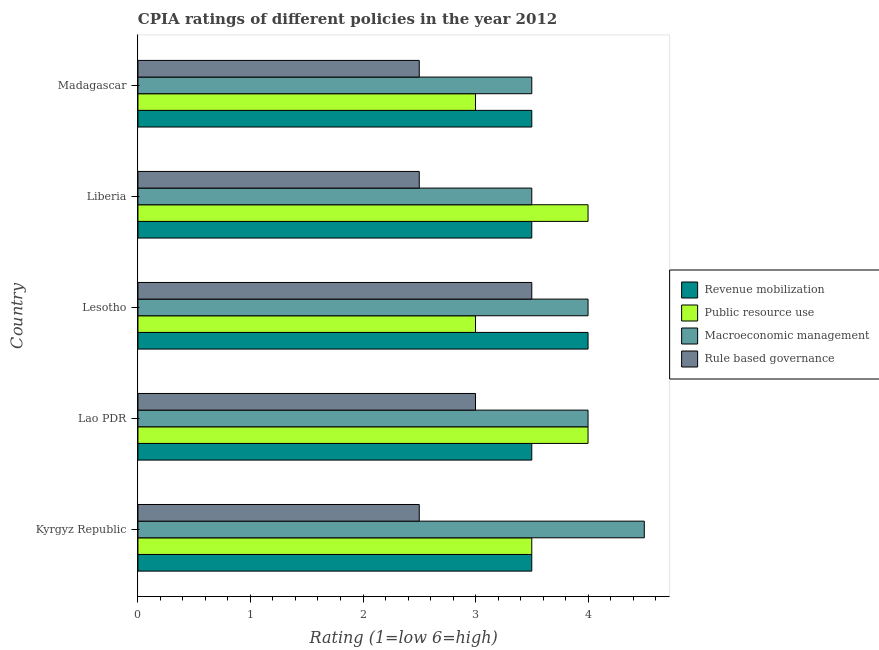Are the number of bars on each tick of the Y-axis equal?
Offer a terse response. Yes. How many bars are there on the 2nd tick from the bottom?
Provide a succinct answer. 4. What is the label of the 1st group of bars from the top?
Provide a succinct answer. Madagascar. In which country was the cpia rating of revenue mobilization maximum?
Offer a very short reply. Lesotho. In which country was the cpia rating of revenue mobilization minimum?
Provide a succinct answer. Kyrgyz Republic. What is the total cpia rating of macroeconomic management in the graph?
Offer a very short reply. 19.5. What is the difference between the cpia rating of macroeconomic management in Kyrgyz Republic and the cpia rating of public resource use in Liberia?
Your answer should be compact. 0.5. What is the average cpia rating of public resource use per country?
Keep it short and to the point. 3.5. What is the difference between the cpia rating of public resource use and cpia rating of revenue mobilization in Madagascar?
Provide a short and direct response. -0.5. In how many countries, is the cpia rating of macroeconomic management greater than 4.4 ?
Your response must be concise. 1. What is the ratio of the cpia rating of revenue mobilization in Kyrgyz Republic to that in Liberia?
Make the answer very short. 1. Is the cpia rating of macroeconomic management in Kyrgyz Republic less than that in Lao PDR?
Give a very brief answer. No. Is the difference between the cpia rating of macroeconomic management in Lesotho and Madagascar greater than the difference between the cpia rating of revenue mobilization in Lesotho and Madagascar?
Give a very brief answer. No. What is the difference between the highest and the lowest cpia rating of macroeconomic management?
Provide a succinct answer. 1. In how many countries, is the cpia rating of macroeconomic management greater than the average cpia rating of macroeconomic management taken over all countries?
Provide a succinct answer. 3. Is the sum of the cpia rating of revenue mobilization in Kyrgyz Republic and Liberia greater than the maximum cpia rating of rule based governance across all countries?
Provide a short and direct response. Yes. Is it the case that in every country, the sum of the cpia rating of macroeconomic management and cpia rating of public resource use is greater than the sum of cpia rating of rule based governance and cpia rating of revenue mobilization?
Your answer should be very brief. No. What does the 4th bar from the top in Liberia represents?
Keep it short and to the point. Revenue mobilization. What does the 1st bar from the bottom in Lesotho represents?
Give a very brief answer. Revenue mobilization. Is it the case that in every country, the sum of the cpia rating of revenue mobilization and cpia rating of public resource use is greater than the cpia rating of macroeconomic management?
Ensure brevity in your answer.  Yes. How many bars are there?
Make the answer very short. 20. How many countries are there in the graph?
Make the answer very short. 5. What is the difference between two consecutive major ticks on the X-axis?
Your answer should be very brief. 1. Where does the legend appear in the graph?
Provide a succinct answer. Center right. What is the title of the graph?
Provide a short and direct response. CPIA ratings of different policies in the year 2012. Does "SF6 gas" appear as one of the legend labels in the graph?
Provide a short and direct response. No. What is the label or title of the Y-axis?
Your answer should be compact. Country. What is the Rating (1=low 6=high) in Public resource use in Kyrgyz Republic?
Make the answer very short. 3.5. What is the Rating (1=low 6=high) of Rule based governance in Kyrgyz Republic?
Your answer should be compact. 2.5. What is the Rating (1=low 6=high) in Macroeconomic management in Lao PDR?
Ensure brevity in your answer.  4. What is the Rating (1=low 6=high) of Rule based governance in Lao PDR?
Give a very brief answer. 3. What is the Rating (1=low 6=high) in Rule based governance in Lesotho?
Ensure brevity in your answer.  3.5. What is the Rating (1=low 6=high) in Public resource use in Liberia?
Give a very brief answer. 4. What is the Rating (1=low 6=high) in Macroeconomic management in Liberia?
Keep it short and to the point. 3.5. What is the Rating (1=low 6=high) of Rule based governance in Liberia?
Keep it short and to the point. 2.5. What is the Rating (1=low 6=high) of Revenue mobilization in Madagascar?
Keep it short and to the point. 3.5. What is the Rating (1=low 6=high) of Public resource use in Madagascar?
Make the answer very short. 3. What is the Rating (1=low 6=high) in Rule based governance in Madagascar?
Give a very brief answer. 2.5. Across all countries, what is the maximum Rating (1=low 6=high) in Macroeconomic management?
Provide a succinct answer. 4.5. Across all countries, what is the minimum Rating (1=low 6=high) in Public resource use?
Give a very brief answer. 3. What is the total Rating (1=low 6=high) of Revenue mobilization in the graph?
Give a very brief answer. 18. What is the total Rating (1=low 6=high) of Macroeconomic management in the graph?
Your response must be concise. 19.5. What is the difference between the Rating (1=low 6=high) in Rule based governance in Kyrgyz Republic and that in Liberia?
Provide a short and direct response. 0. What is the difference between the Rating (1=low 6=high) in Revenue mobilization in Kyrgyz Republic and that in Madagascar?
Give a very brief answer. 0. What is the difference between the Rating (1=low 6=high) in Macroeconomic management in Kyrgyz Republic and that in Madagascar?
Your answer should be compact. 1. What is the difference between the Rating (1=low 6=high) in Public resource use in Lao PDR and that in Lesotho?
Your answer should be very brief. 1. What is the difference between the Rating (1=low 6=high) in Rule based governance in Lao PDR and that in Lesotho?
Offer a terse response. -0.5. What is the difference between the Rating (1=low 6=high) of Revenue mobilization in Lao PDR and that in Liberia?
Your answer should be compact. 0. What is the difference between the Rating (1=low 6=high) of Macroeconomic management in Lao PDR and that in Liberia?
Ensure brevity in your answer.  0.5. What is the difference between the Rating (1=low 6=high) of Public resource use in Lesotho and that in Liberia?
Your answer should be very brief. -1. What is the difference between the Rating (1=low 6=high) of Revenue mobilization in Liberia and that in Madagascar?
Give a very brief answer. 0. What is the difference between the Rating (1=low 6=high) in Macroeconomic management in Kyrgyz Republic and the Rating (1=low 6=high) in Rule based governance in Lao PDR?
Offer a very short reply. 1.5. What is the difference between the Rating (1=low 6=high) in Revenue mobilization in Kyrgyz Republic and the Rating (1=low 6=high) in Public resource use in Lesotho?
Make the answer very short. 0.5. What is the difference between the Rating (1=low 6=high) in Revenue mobilization in Kyrgyz Republic and the Rating (1=low 6=high) in Macroeconomic management in Lesotho?
Provide a short and direct response. -0.5. What is the difference between the Rating (1=low 6=high) in Revenue mobilization in Kyrgyz Republic and the Rating (1=low 6=high) in Rule based governance in Lesotho?
Keep it short and to the point. 0. What is the difference between the Rating (1=low 6=high) of Revenue mobilization in Kyrgyz Republic and the Rating (1=low 6=high) of Public resource use in Liberia?
Make the answer very short. -0.5. What is the difference between the Rating (1=low 6=high) in Revenue mobilization in Kyrgyz Republic and the Rating (1=low 6=high) in Rule based governance in Liberia?
Your answer should be compact. 1. What is the difference between the Rating (1=low 6=high) of Public resource use in Kyrgyz Republic and the Rating (1=low 6=high) of Macroeconomic management in Liberia?
Keep it short and to the point. 0. What is the difference between the Rating (1=low 6=high) in Macroeconomic management in Kyrgyz Republic and the Rating (1=low 6=high) in Rule based governance in Liberia?
Make the answer very short. 2. What is the difference between the Rating (1=low 6=high) of Revenue mobilization in Kyrgyz Republic and the Rating (1=low 6=high) of Rule based governance in Madagascar?
Ensure brevity in your answer.  1. What is the difference between the Rating (1=low 6=high) of Public resource use in Kyrgyz Republic and the Rating (1=low 6=high) of Macroeconomic management in Madagascar?
Give a very brief answer. 0. What is the difference between the Rating (1=low 6=high) of Public resource use in Kyrgyz Republic and the Rating (1=low 6=high) of Rule based governance in Madagascar?
Your response must be concise. 1. What is the difference between the Rating (1=low 6=high) of Macroeconomic management in Kyrgyz Republic and the Rating (1=low 6=high) of Rule based governance in Madagascar?
Provide a short and direct response. 2. What is the difference between the Rating (1=low 6=high) of Macroeconomic management in Lao PDR and the Rating (1=low 6=high) of Rule based governance in Lesotho?
Offer a terse response. 0.5. What is the difference between the Rating (1=low 6=high) of Revenue mobilization in Lao PDR and the Rating (1=low 6=high) of Macroeconomic management in Liberia?
Ensure brevity in your answer.  0. What is the difference between the Rating (1=low 6=high) of Revenue mobilization in Lao PDR and the Rating (1=low 6=high) of Rule based governance in Liberia?
Ensure brevity in your answer.  1. What is the difference between the Rating (1=low 6=high) in Public resource use in Lao PDR and the Rating (1=low 6=high) in Macroeconomic management in Liberia?
Keep it short and to the point. 0.5. What is the difference between the Rating (1=low 6=high) in Revenue mobilization in Lao PDR and the Rating (1=low 6=high) in Macroeconomic management in Madagascar?
Ensure brevity in your answer.  0. What is the difference between the Rating (1=low 6=high) of Revenue mobilization in Lao PDR and the Rating (1=low 6=high) of Rule based governance in Madagascar?
Provide a succinct answer. 1. What is the difference between the Rating (1=low 6=high) in Macroeconomic management in Lao PDR and the Rating (1=low 6=high) in Rule based governance in Madagascar?
Make the answer very short. 1.5. What is the difference between the Rating (1=low 6=high) in Revenue mobilization in Lesotho and the Rating (1=low 6=high) in Public resource use in Liberia?
Ensure brevity in your answer.  0. What is the difference between the Rating (1=low 6=high) in Public resource use in Lesotho and the Rating (1=low 6=high) in Macroeconomic management in Liberia?
Ensure brevity in your answer.  -0.5. What is the difference between the Rating (1=low 6=high) of Macroeconomic management in Lesotho and the Rating (1=low 6=high) of Rule based governance in Liberia?
Make the answer very short. 1.5. What is the difference between the Rating (1=low 6=high) in Revenue mobilization in Lesotho and the Rating (1=low 6=high) in Public resource use in Madagascar?
Ensure brevity in your answer.  1. What is the difference between the Rating (1=low 6=high) of Revenue mobilization in Lesotho and the Rating (1=low 6=high) of Macroeconomic management in Madagascar?
Your response must be concise. 0.5. What is the difference between the Rating (1=low 6=high) in Macroeconomic management in Lesotho and the Rating (1=low 6=high) in Rule based governance in Madagascar?
Provide a short and direct response. 1.5. What is the difference between the Rating (1=low 6=high) in Revenue mobilization in Liberia and the Rating (1=low 6=high) in Macroeconomic management in Madagascar?
Keep it short and to the point. 0. What is the difference between the Rating (1=low 6=high) of Public resource use in Liberia and the Rating (1=low 6=high) of Macroeconomic management in Madagascar?
Your response must be concise. 0.5. What is the difference between the Rating (1=low 6=high) of Public resource use in Liberia and the Rating (1=low 6=high) of Rule based governance in Madagascar?
Your response must be concise. 1.5. What is the average Rating (1=low 6=high) in Public resource use per country?
Your answer should be compact. 3.5. What is the average Rating (1=low 6=high) in Macroeconomic management per country?
Give a very brief answer. 3.9. What is the difference between the Rating (1=low 6=high) of Revenue mobilization and Rating (1=low 6=high) of Public resource use in Kyrgyz Republic?
Your answer should be very brief. 0. What is the difference between the Rating (1=low 6=high) in Revenue mobilization and Rating (1=low 6=high) in Macroeconomic management in Kyrgyz Republic?
Offer a terse response. -1. What is the difference between the Rating (1=low 6=high) in Revenue mobilization and Rating (1=low 6=high) in Rule based governance in Kyrgyz Republic?
Offer a very short reply. 1. What is the difference between the Rating (1=low 6=high) of Public resource use and Rating (1=low 6=high) of Rule based governance in Kyrgyz Republic?
Make the answer very short. 1. What is the difference between the Rating (1=low 6=high) in Macroeconomic management and Rating (1=low 6=high) in Rule based governance in Kyrgyz Republic?
Provide a short and direct response. 2. What is the difference between the Rating (1=low 6=high) in Revenue mobilization and Rating (1=low 6=high) in Macroeconomic management in Lao PDR?
Keep it short and to the point. -0.5. What is the difference between the Rating (1=low 6=high) of Revenue mobilization and Rating (1=low 6=high) of Rule based governance in Lao PDR?
Keep it short and to the point. 0.5. What is the difference between the Rating (1=low 6=high) in Public resource use and Rating (1=low 6=high) in Macroeconomic management in Lao PDR?
Your response must be concise. 0. What is the difference between the Rating (1=low 6=high) in Macroeconomic management and Rating (1=low 6=high) in Rule based governance in Lao PDR?
Keep it short and to the point. 1. What is the difference between the Rating (1=low 6=high) of Revenue mobilization and Rating (1=low 6=high) of Rule based governance in Lesotho?
Provide a succinct answer. 0.5. What is the difference between the Rating (1=low 6=high) in Public resource use and Rating (1=low 6=high) in Macroeconomic management in Lesotho?
Ensure brevity in your answer.  -1. What is the difference between the Rating (1=low 6=high) of Revenue mobilization and Rating (1=low 6=high) of Rule based governance in Liberia?
Offer a very short reply. 1. What is the difference between the Rating (1=low 6=high) of Public resource use and Rating (1=low 6=high) of Macroeconomic management in Liberia?
Provide a short and direct response. 0.5. What is the difference between the Rating (1=low 6=high) of Macroeconomic management and Rating (1=low 6=high) of Rule based governance in Liberia?
Give a very brief answer. 1. What is the difference between the Rating (1=low 6=high) in Public resource use and Rating (1=low 6=high) in Macroeconomic management in Madagascar?
Provide a succinct answer. -0.5. What is the difference between the Rating (1=low 6=high) in Public resource use and Rating (1=low 6=high) in Rule based governance in Madagascar?
Keep it short and to the point. 0.5. What is the difference between the Rating (1=low 6=high) in Macroeconomic management and Rating (1=low 6=high) in Rule based governance in Madagascar?
Ensure brevity in your answer.  1. What is the ratio of the Rating (1=low 6=high) of Revenue mobilization in Kyrgyz Republic to that in Lao PDR?
Provide a succinct answer. 1. What is the ratio of the Rating (1=low 6=high) in Revenue mobilization in Kyrgyz Republic to that in Liberia?
Your answer should be very brief. 1. What is the ratio of the Rating (1=low 6=high) of Public resource use in Kyrgyz Republic to that in Liberia?
Give a very brief answer. 0.88. What is the ratio of the Rating (1=low 6=high) in Macroeconomic management in Kyrgyz Republic to that in Liberia?
Make the answer very short. 1.29. What is the ratio of the Rating (1=low 6=high) in Revenue mobilization in Kyrgyz Republic to that in Madagascar?
Offer a very short reply. 1. What is the ratio of the Rating (1=low 6=high) of Public resource use in Kyrgyz Republic to that in Madagascar?
Give a very brief answer. 1.17. What is the ratio of the Rating (1=low 6=high) in Macroeconomic management in Kyrgyz Republic to that in Madagascar?
Give a very brief answer. 1.29. What is the ratio of the Rating (1=low 6=high) in Rule based governance in Kyrgyz Republic to that in Madagascar?
Make the answer very short. 1. What is the ratio of the Rating (1=low 6=high) in Revenue mobilization in Lao PDR to that in Lesotho?
Make the answer very short. 0.88. What is the ratio of the Rating (1=low 6=high) of Rule based governance in Lao PDR to that in Lesotho?
Offer a very short reply. 0.86. What is the ratio of the Rating (1=low 6=high) of Macroeconomic management in Lao PDR to that in Liberia?
Provide a succinct answer. 1.14. What is the ratio of the Rating (1=low 6=high) in Rule based governance in Lao PDR to that in Liberia?
Your answer should be very brief. 1.2. What is the ratio of the Rating (1=low 6=high) of Revenue mobilization in Lesotho to that in Liberia?
Provide a short and direct response. 1.14. What is the ratio of the Rating (1=low 6=high) in Public resource use in Lesotho to that in Liberia?
Give a very brief answer. 0.75. What is the ratio of the Rating (1=low 6=high) in Rule based governance in Lesotho to that in Liberia?
Ensure brevity in your answer.  1.4. What is the ratio of the Rating (1=low 6=high) of Revenue mobilization in Lesotho to that in Madagascar?
Your answer should be very brief. 1.14. What is the ratio of the Rating (1=low 6=high) in Public resource use in Liberia to that in Madagascar?
Your response must be concise. 1.33. What is the difference between the highest and the second highest Rating (1=low 6=high) of Public resource use?
Give a very brief answer. 0. What is the difference between the highest and the second highest Rating (1=low 6=high) in Macroeconomic management?
Ensure brevity in your answer.  0.5. What is the difference between the highest and the lowest Rating (1=low 6=high) of Revenue mobilization?
Keep it short and to the point. 0.5. What is the difference between the highest and the lowest Rating (1=low 6=high) in Macroeconomic management?
Give a very brief answer. 1. What is the difference between the highest and the lowest Rating (1=low 6=high) in Rule based governance?
Your response must be concise. 1. 